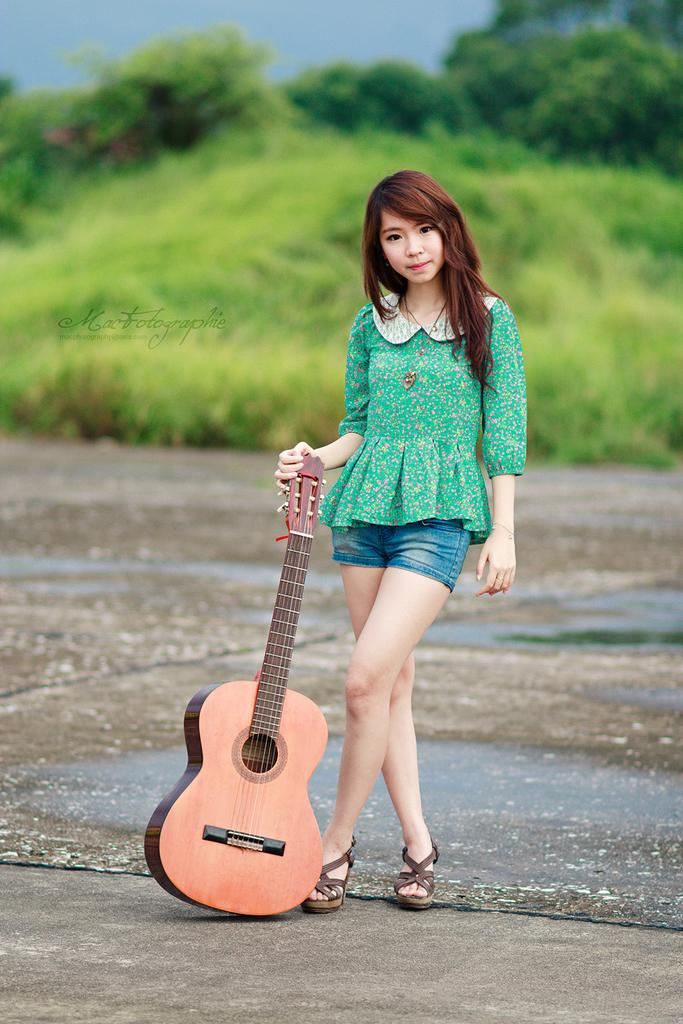Who is the main subject in the image? There is a girl in the image. Where is the girl positioned in the image? The girl is standing at the center of the image. What is the girl holding in the image? The girl is holding a guitar. What can be seen in the background of the image? There are trees visible in the background of the image. What type of soup is the girl eating in the image? There is no soup present in the image; the girl is holding a guitar. Can you tell me how many cabbages are visible in the image? There are no cabbages present in the image; the background features trees. 